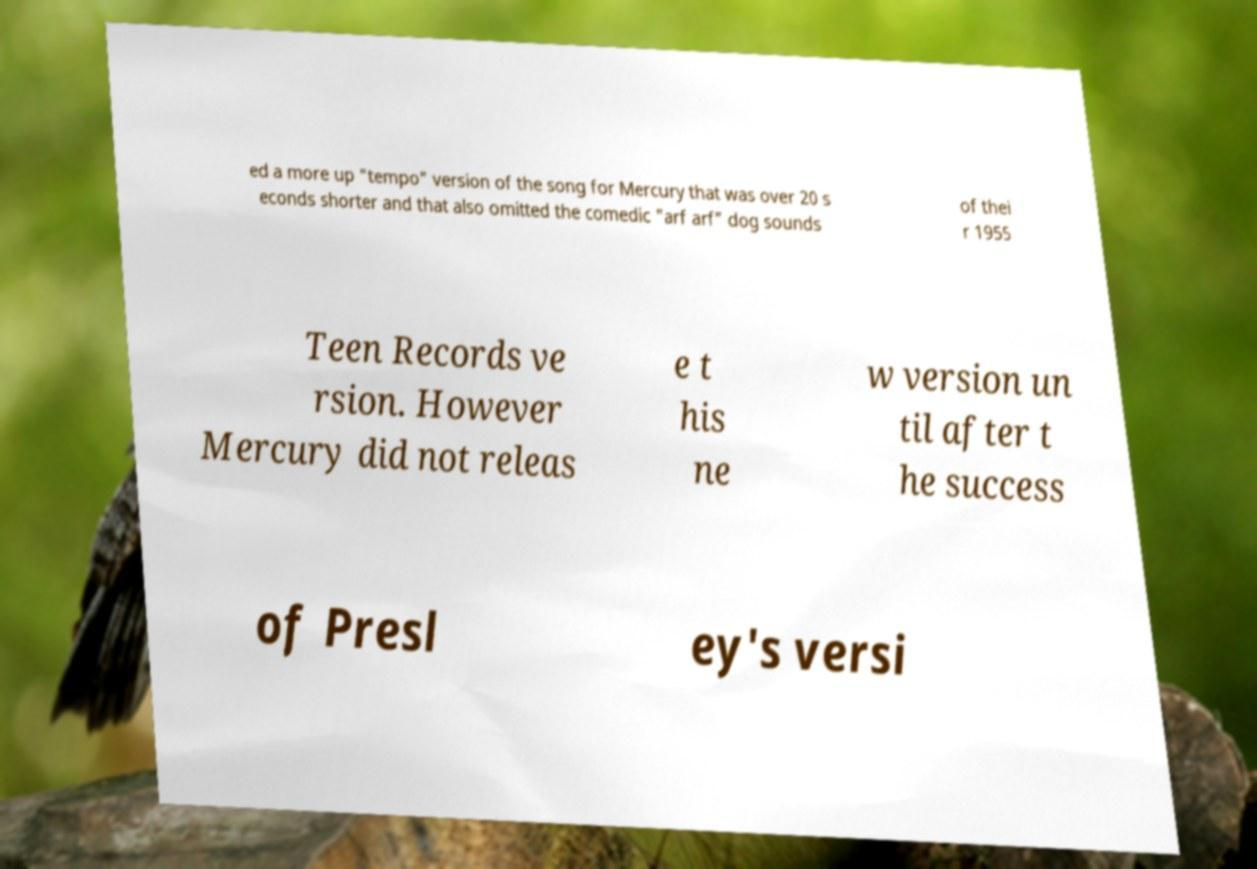I need the written content from this picture converted into text. Can you do that? ed a more up "tempo" version of the song for Mercury that was over 20 s econds shorter and that also omitted the comedic "arf arf" dog sounds of thei r 1955 Teen Records ve rsion. However Mercury did not releas e t his ne w version un til after t he success of Presl ey's versi 